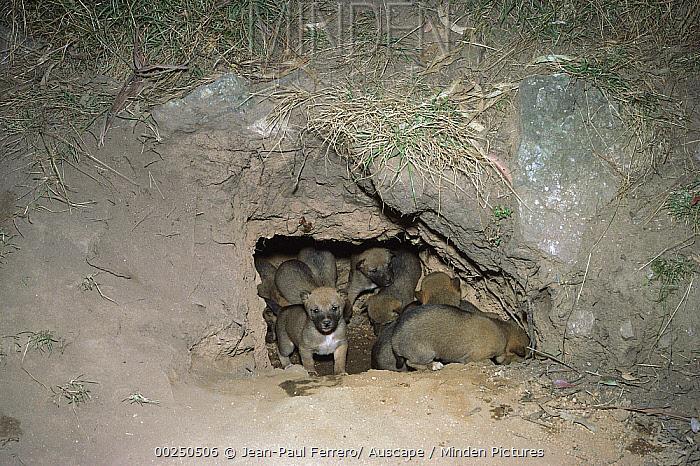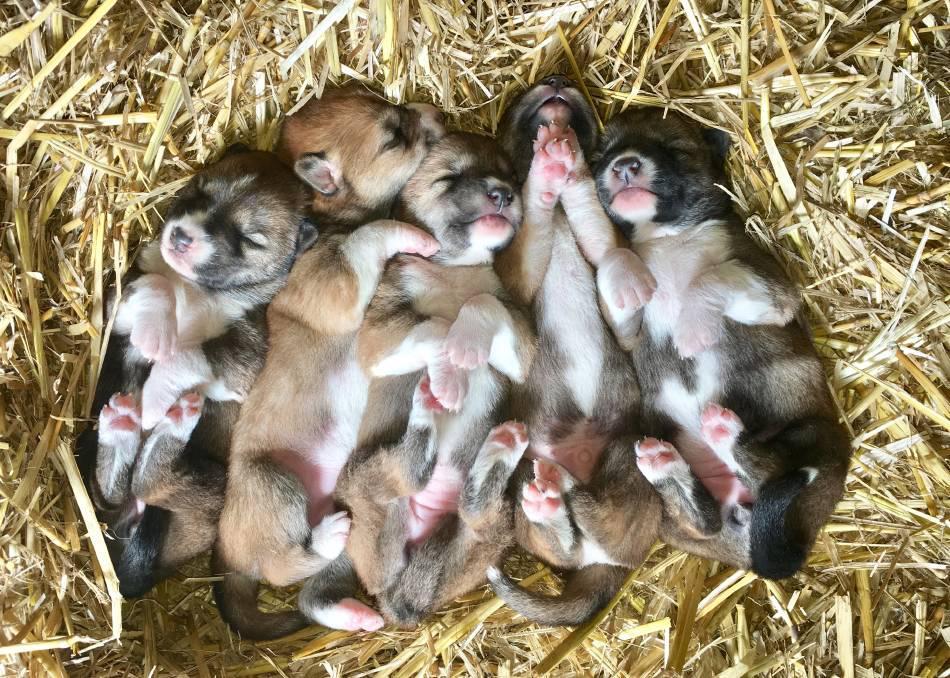The first image is the image on the left, the second image is the image on the right. Considering the images on both sides, is "One image shows only multiple pups, and the other image shows a mother dog with pups." valid? Answer yes or no. No. The first image is the image on the left, the second image is the image on the right. Analyze the images presented: Is the assertion "In the image on the right several puppies are nestled on straw." valid? Answer yes or no. Yes. 